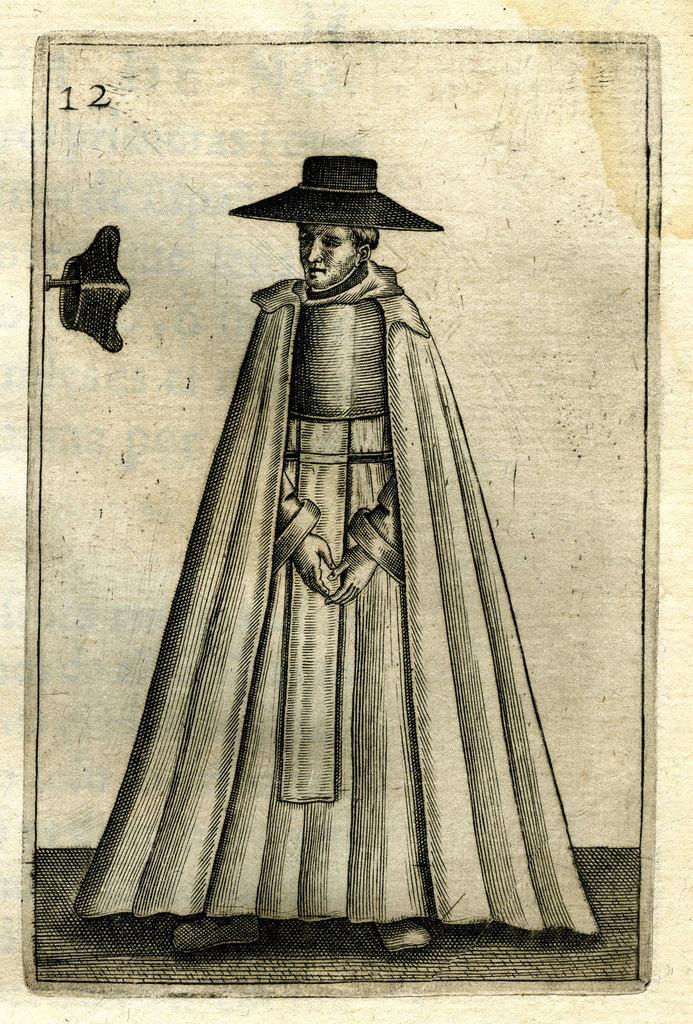How would you summarize this image in a sentence or two? In this picture i can see the poster. In the center there is a man who is wearing hat and dress. Beside him i can see another hat which is kept on the needle. 